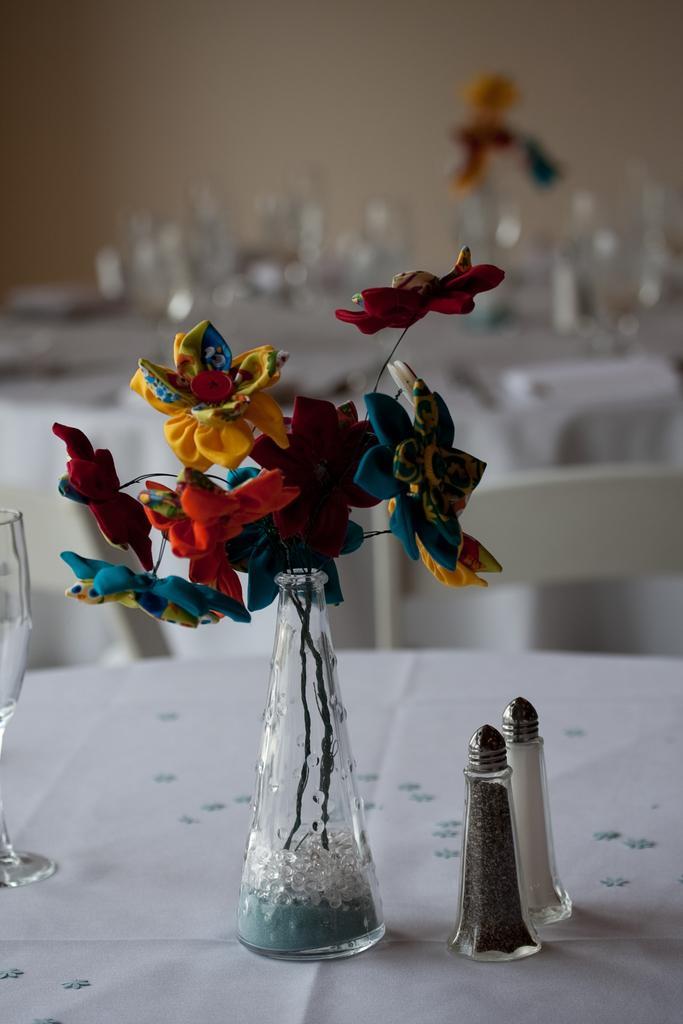Could you give a brief overview of what you see in this image? In front of the image there are condiments, flower vase and condiments on a table, in the background of the image there are some objects on the table with empty chairs in front of it, in the background of the image there is a wall. 